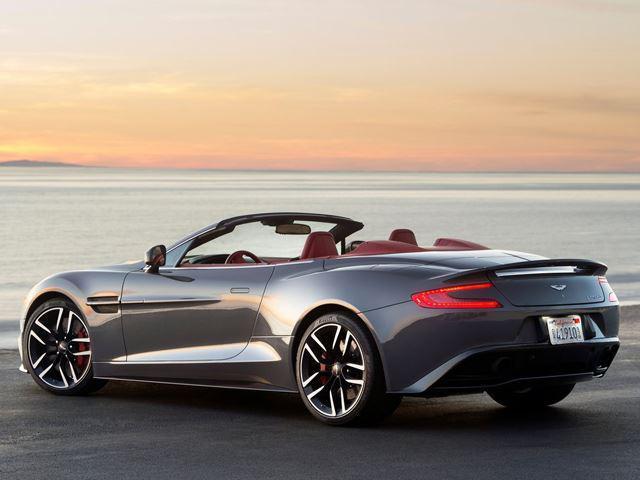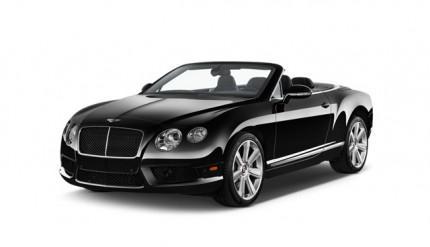The first image is the image on the left, the second image is the image on the right. Analyze the images presented: Is the assertion "One image shows a topless black convertible aimed leftward." valid? Answer yes or no. Yes. The first image is the image on the left, the second image is the image on the right. Analyze the images presented: Is the assertion "There is no less than one black convertible car with its top down" valid? Answer yes or no. Yes. 